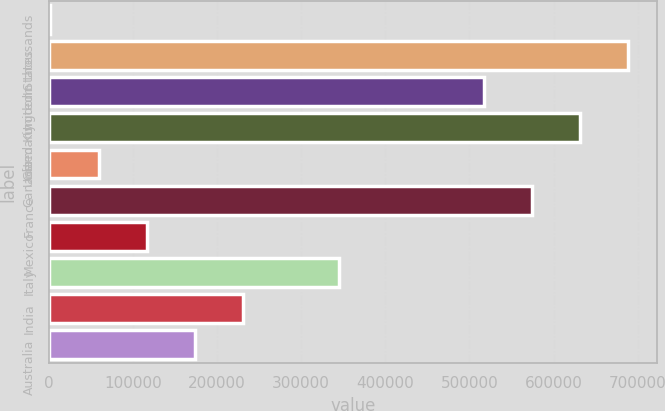<chart> <loc_0><loc_0><loc_500><loc_500><bar_chart><fcel>In thousands<fcel>United States<fcel>United Kingdom<fcel>Germany<fcel>Canada<fcel>France<fcel>Mexico<fcel>Italy<fcel>India<fcel>Australia<nl><fcel>2017<fcel>688363<fcel>516776<fcel>631168<fcel>59212.5<fcel>573972<fcel>116408<fcel>345190<fcel>230799<fcel>173604<nl></chart> 